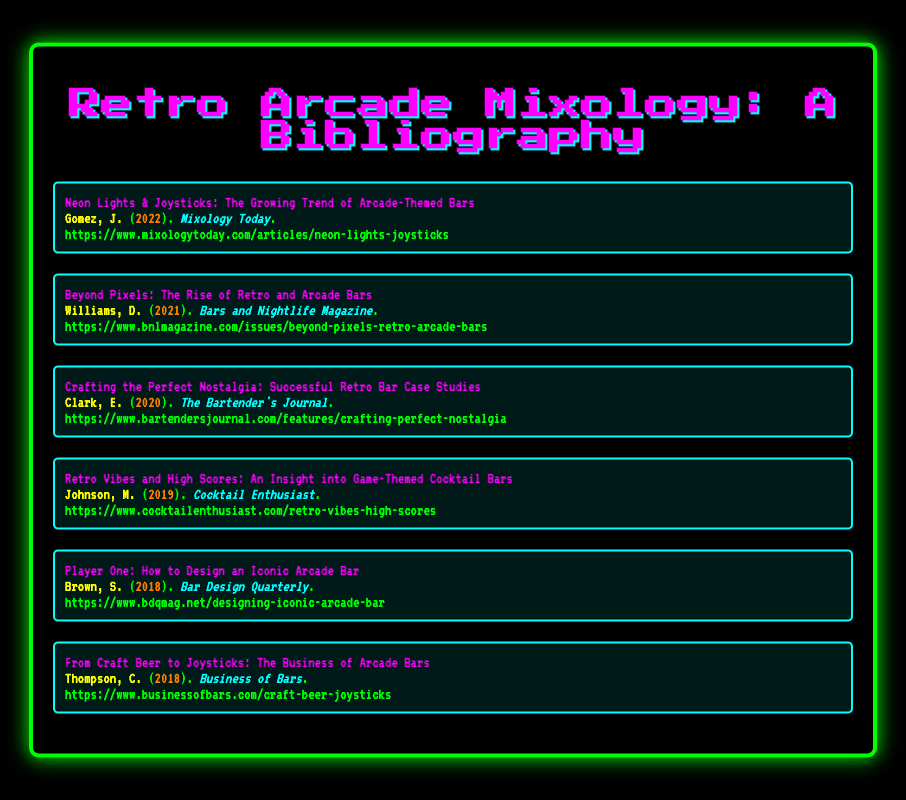what is the title of the first entry? The title of the first entry is found in the first list item under "title".
Answer: Neon Lights & Joysticks: The Growing Trend of Arcade-Themed Bars who is the author of the article published in 2019? The author's name for the 2019 publication can be found beside the publication year in the fourth entry.
Answer: Johnson, M in which year was "Crafting the Perfect Nostalgia" published? The publication year for "Crafting the Perfect Nostalgia" is directly stated next to the title and author in the third entry.
Answer: 2020 how many articles are listed in the bibliography? The total count of list items determines the number of articles, which is given at a glance.
Answer: 6 which publication featured the article "Player One: How to Design an Iconic Arcade Bar"? The publication name is located in the fifth entry, immediately following the author and year.
Answer: Bar Design Quarterly which theme do most articles in this bibliography focus on? The overarching theme can be inferred from the titles of the articles.
Answer: Arcade bars who published the article regarding the business of arcade bars? The author's name is listed next to the title in the sixth entry on business-related insights for arcade bars.
Answer: Thompson, C 